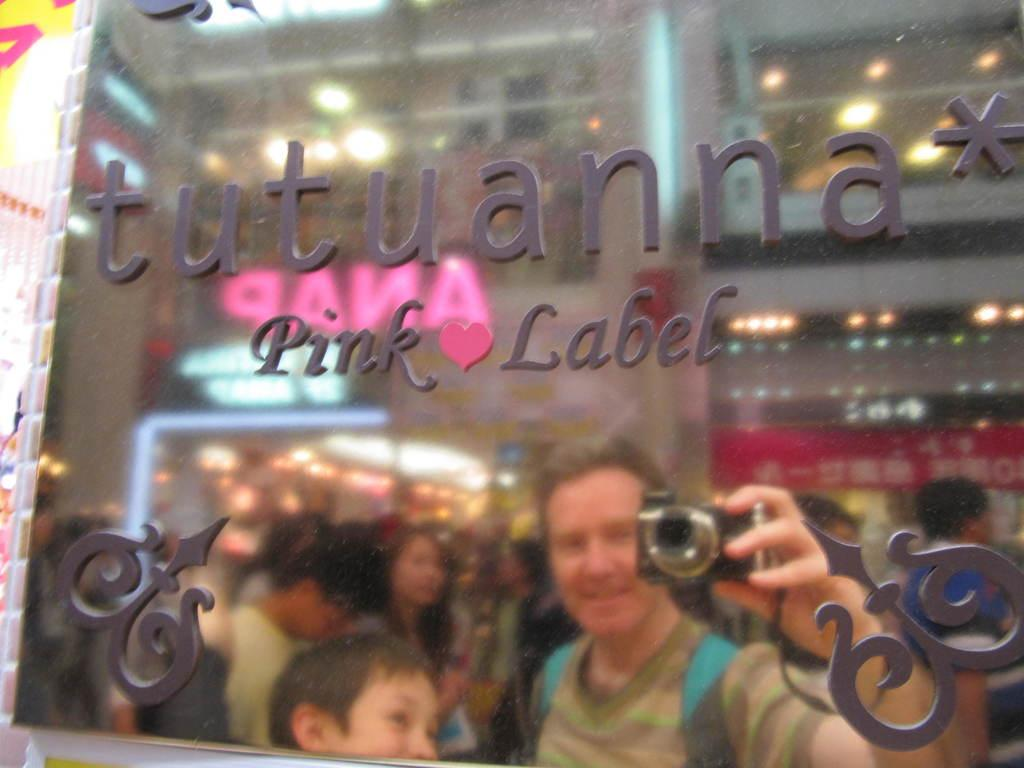What is the main subject of the image? The main subject of the image is an advertisement board. What can be seen in the reflection of the board? In the reflection of the board, persons, name boards, walls, and electric lights can be seen. What type of treatment is being offered for the root in the image? There is no root or treatment mentioned in the image; it features an advertisement board and its reflection. 